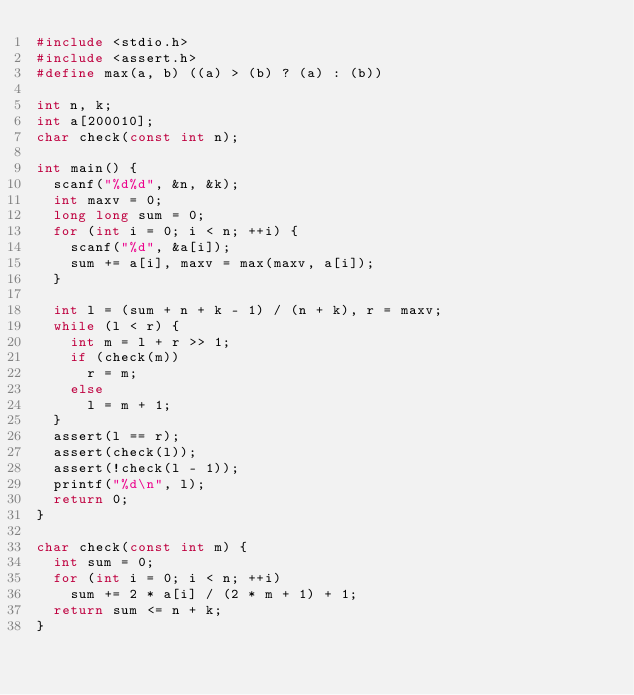<code> <loc_0><loc_0><loc_500><loc_500><_C_>#include <stdio.h>
#include <assert.h>
#define max(a, b) ((a) > (b) ? (a) : (b))

int n, k;
int a[200010];
char check(const int n);

int main() {
	scanf("%d%d", &n, &k);
	int maxv = 0;
	long long sum = 0;
	for (int i = 0; i < n; ++i) {
		scanf("%d", &a[i]);
		sum += a[i], maxv = max(maxv, a[i]);
	}
	
	int l = (sum + n + k - 1) / (n + k), r = maxv;
	while (l < r) {
		int m = l + r >> 1;
		if (check(m))
			r = m;
		else
			l = m + 1;
	}
	assert(l == r);
	assert(check(l));
	assert(!check(l - 1));
	printf("%d\n", l);
	return 0;
}

char check(const int m) {
	int sum = 0;
	for (int i = 0; i < n; ++i)
		sum += 2 * a[i] / (2 * m + 1) + 1;
	return sum <= n + k;
}

</code> 